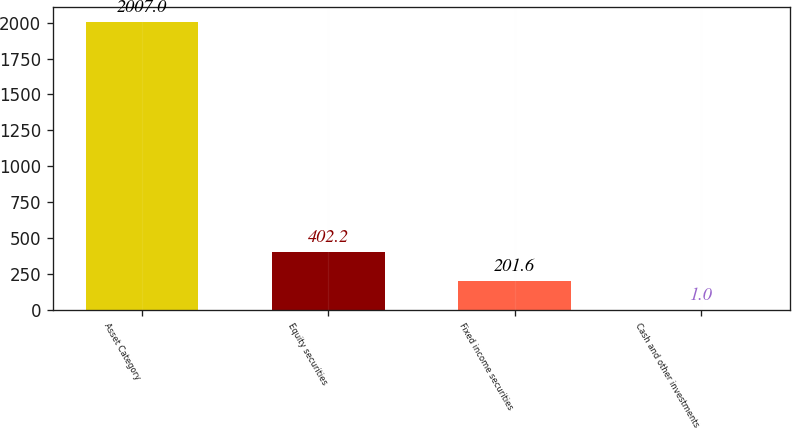Convert chart. <chart><loc_0><loc_0><loc_500><loc_500><bar_chart><fcel>Asset Category<fcel>Equity securities<fcel>Fixed income securities<fcel>Cash and other investments<nl><fcel>2007<fcel>402.2<fcel>201.6<fcel>1<nl></chart> 